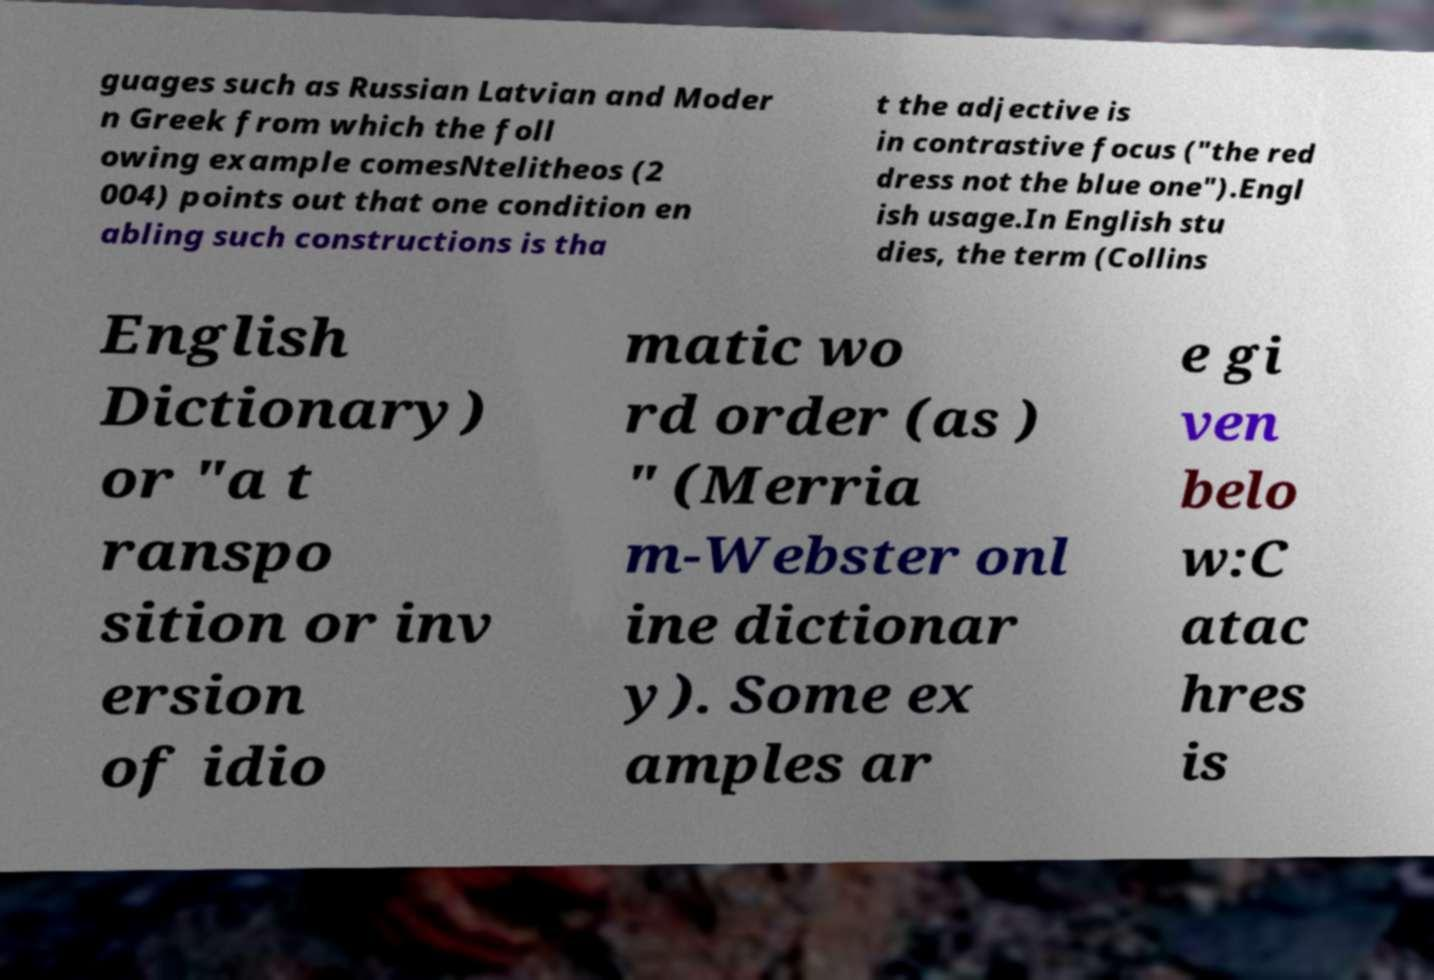For documentation purposes, I need the text within this image transcribed. Could you provide that? guages such as Russian Latvian and Moder n Greek from which the foll owing example comesNtelitheos (2 004) points out that one condition en abling such constructions is tha t the adjective is in contrastive focus ("the red dress not the blue one").Engl ish usage.In English stu dies, the term (Collins English Dictionary) or "a t ranspo sition or inv ersion of idio matic wo rd order (as ) " (Merria m-Webster onl ine dictionar y). Some ex amples ar e gi ven belo w:C atac hres is 